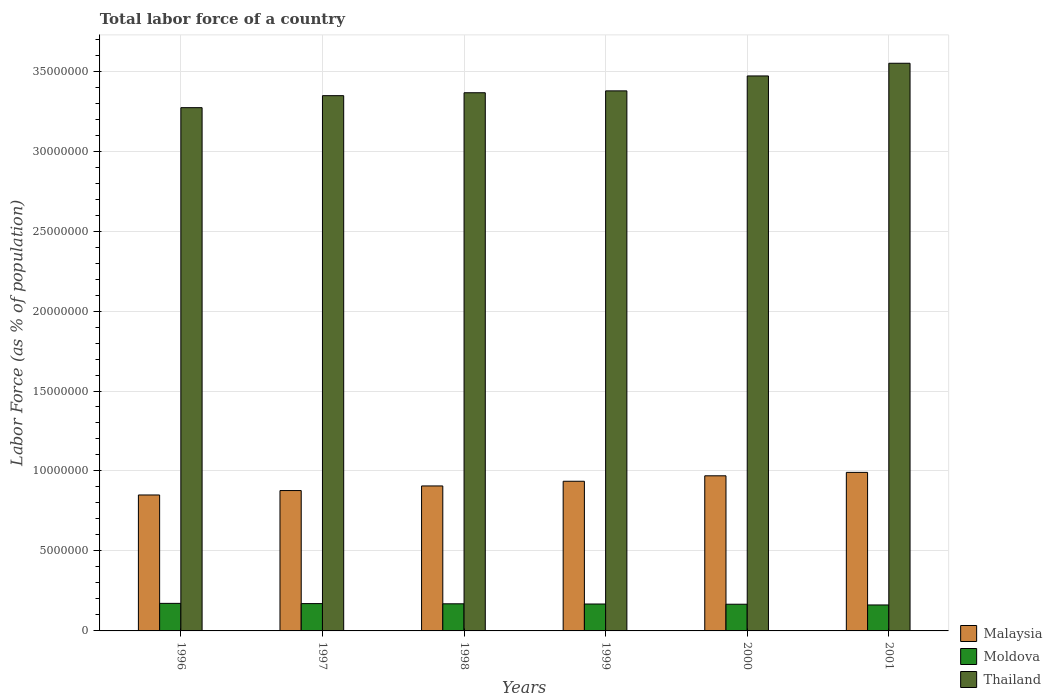How many bars are there on the 4th tick from the right?
Your answer should be very brief. 3. What is the label of the 5th group of bars from the left?
Provide a short and direct response. 2000. What is the percentage of labor force in Moldova in 1997?
Your response must be concise. 1.71e+06. Across all years, what is the maximum percentage of labor force in Moldova?
Your answer should be very brief. 1.72e+06. Across all years, what is the minimum percentage of labor force in Thailand?
Offer a terse response. 3.27e+07. In which year was the percentage of labor force in Thailand minimum?
Your answer should be very brief. 1996. What is the total percentage of labor force in Thailand in the graph?
Your answer should be very brief. 2.04e+08. What is the difference between the percentage of labor force in Moldova in 1997 and that in 1999?
Keep it short and to the point. 2.49e+04. What is the difference between the percentage of labor force in Malaysia in 2000 and the percentage of labor force in Thailand in 2001?
Offer a very short reply. -2.58e+07. What is the average percentage of labor force in Malaysia per year?
Ensure brevity in your answer.  9.22e+06. In the year 1998, what is the difference between the percentage of labor force in Thailand and percentage of labor force in Moldova?
Make the answer very short. 3.20e+07. In how many years, is the percentage of labor force in Thailand greater than 26000000 %?
Your answer should be very brief. 6. What is the ratio of the percentage of labor force in Thailand in 1997 to that in 2000?
Offer a very short reply. 0.96. Is the percentage of labor force in Malaysia in 1996 less than that in 1998?
Your response must be concise. Yes. Is the difference between the percentage of labor force in Thailand in 1996 and 2000 greater than the difference between the percentage of labor force in Moldova in 1996 and 2000?
Your answer should be very brief. No. What is the difference between the highest and the second highest percentage of labor force in Malaysia?
Your answer should be very brief. 2.13e+05. What is the difference between the highest and the lowest percentage of labor force in Thailand?
Your answer should be compact. 2.78e+06. In how many years, is the percentage of labor force in Malaysia greater than the average percentage of labor force in Malaysia taken over all years?
Offer a very short reply. 3. What does the 1st bar from the left in 2000 represents?
Offer a very short reply. Malaysia. What does the 3rd bar from the right in 1999 represents?
Provide a short and direct response. Malaysia. Are all the bars in the graph horizontal?
Offer a very short reply. No. How many years are there in the graph?
Your answer should be very brief. 6. Does the graph contain any zero values?
Your response must be concise. No. Does the graph contain grids?
Offer a terse response. Yes. How many legend labels are there?
Offer a terse response. 3. How are the legend labels stacked?
Provide a succinct answer. Vertical. What is the title of the graph?
Offer a terse response. Total labor force of a country. Does "Kosovo" appear as one of the legend labels in the graph?
Your response must be concise. No. What is the label or title of the Y-axis?
Provide a short and direct response. Labor Force (as % of population). What is the Labor Force (as % of population) in Malaysia in 1996?
Offer a terse response. 8.50e+06. What is the Labor Force (as % of population) in Moldova in 1996?
Give a very brief answer. 1.72e+06. What is the Labor Force (as % of population) of Thailand in 1996?
Keep it short and to the point. 3.27e+07. What is the Labor Force (as % of population) of Malaysia in 1997?
Ensure brevity in your answer.  8.78e+06. What is the Labor Force (as % of population) of Moldova in 1997?
Offer a terse response. 1.71e+06. What is the Labor Force (as % of population) of Thailand in 1997?
Provide a short and direct response. 3.35e+07. What is the Labor Force (as % of population) of Malaysia in 1998?
Your response must be concise. 9.06e+06. What is the Labor Force (as % of population) of Moldova in 1998?
Your answer should be compact. 1.70e+06. What is the Labor Force (as % of population) of Thailand in 1998?
Make the answer very short. 3.36e+07. What is the Labor Force (as % of population) in Malaysia in 1999?
Keep it short and to the point. 9.36e+06. What is the Labor Force (as % of population) in Moldova in 1999?
Your answer should be compact. 1.68e+06. What is the Labor Force (as % of population) of Thailand in 1999?
Your response must be concise. 3.38e+07. What is the Labor Force (as % of population) of Malaysia in 2000?
Keep it short and to the point. 9.70e+06. What is the Labor Force (as % of population) in Moldova in 2000?
Your answer should be very brief. 1.67e+06. What is the Labor Force (as % of population) of Thailand in 2000?
Your answer should be compact. 3.47e+07. What is the Labor Force (as % of population) in Malaysia in 2001?
Your answer should be compact. 9.91e+06. What is the Labor Force (as % of population) of Moldova in 2001?
Your answer should be very brief. 1.62e+06. What is the Labor Force (as % of population) of Thailand in 2001?
Make the answer very short. 3.55e+07. Across all years, what is the maximum Labor Force (as % of population) of Malaysia?
Offer a very short reply. 9.91e+06. Across all years, what is the maximum Labor Force (as % of population) in Moldova?
Offer a terse response. 1.72e+06. Across all years, what is the maximum Labor Force (as % of population) in Thailand?
Your answer should be very brief. 3.55e+07. Across all years, what is the minimum Labor Force (as % of population) in Malaysia?
Your response must be concise. 8.50e+06. Across all years, what is the minimum Labor Force (as % of population) of Moldova?
Offer a very short reply. 1.62e+06. Across all years, what is the minimum Labor Force (as % of population) in Thailand?
Ensure brevity in your answer.  3.27e+07. What is the total Labor Force (as % of population) in Malaysia in the graph?
Ensure brevity in your answer.  5.53e+07. What is the total Labor Force (as % of population) in Moldova in the graph?
Offer a very short reply. 1.01e+07. What is the total Labor Force (as % of population) of Thailand in the graph?
Your answer should be very brief. 2.04e+08. What is the difference between the Labor Force (as % of population) in Malaysia in 1996 and that in 1997?
Your response must be concise. -2.77e+05. What is the difference between the Labor Force (as % of population) of Moldova in 1996 and that in 1997?
Offer a very short reply. 1.54e+04. What is the difference between the Labor Force (as % of population) in Thailand in 1996 and that in 1997?
Offer a very short reply. -7.50e+05. What is the difference between the Labor Force (as % of population) in Malaysia in 1996 and that in 1998?
Your answer should be compact. -5.64e+05. What is the difference between the Labor Force (as % of population) of Moldova in 1996 and that in 1998?
Provide a short and direct response. 2.77e+04. What is the difference between the Labor Force (as % of population) of Thailand in 1996 and that in 1998?
Your response must be concise. -9.32e+05. What is the difference between the Labor Force (as % of population) of Malaysia in 1996 and that in 1999?
Your response must be concise. -8.58e+05. What is the difference between the Labor Force (as % of population) of Moldova in 1996 and that in 1999?
Your response must be concise. 4.03e+04. What is the difference between the Labor Force (as % of population) in Thailand in 1996 and that in 1999?
Provide a succinct answer. -1.05e+06. What is the difference between the Labor Force (as % of population) of Malaysia in 1996 and that in 2000?
Keep it short and to the point. -1.20e+06. What is the difference between the Labor Force (as % of population) in Moldova in 1996 and that in 2000?
Your response must be concise. 5.42e+04. What is the difference between the Labor Force (as % of population) in Thailand in 1996 and that in 2000?
Keep it short and to the point. -1.98e+06. What is the difference between the Labor Force (as % of population) of Malaysia in 1996 and that in 2001?
Your answer should be compact. -1.41e+06. What is the difference between the Labor Force (as % of population) of Moldova in 1996 and that in 2001?
Provide a short and direct response. 9.94e+04. What is the difference between the Labor Force (as % of population) of Thailand in 1996 and that in 2001?
Your answer should be compact. -2.78e+06. What is the difference between the Labor Force (as % of population) in Malaysia in 1997 and that in 1998?
Ensure brevity in your answer.  -2.88e+05. What is the difference between the Labor Force (as % of population) of Moldova in 1997 and that in 1998?
Make the answer very short. 1.23e+04. What is the difference between the Labor Force (as % of population) in Thailand in 1997 and that in 1998?
Provide a succinct answer. -1.82e+05. What is the difference between the Labor Force (as % of population) of Malaysia in 1997 and that in 1999?
Provide a short and direct response. -5.81e+05. What is the difference between the Labor Force (as % of population) in Moldova in 1997 and that in 1999?
Provide a short and direct response. 2.49e+04. What is the difference between the Labor Force (as % of population) of Thailand in 1997 and that in 1999?
Offer a very short reply. -2.99e+05. What is the difference between the Labor Force (as % of population) in Malaysia in 1997 and that in 2000?
Your answer should be compact. -9.22e+05. What is the difference between the Labor Force (as % of population) of Moldova in 1997 and that in 2000?
Offer a very short reply. 3.88e+04. What is the difference between the Labor Force (as % of population) in Thailand in 1997 and that in 2000?
Make the answer very short. -1.23e+06. What is the difference between the Labor Force (as % of population) in Malaysia in 1997 and that in 2001?
Provide a succinct answer. -1.14e+06. What is the difference between the Labor Force (as % of population) in Moldova in 1997 and that in 2001?
Your response must be concise. 8.40e+04. What is the difference between the Labor Force (as % of population) of Thailand in 1997 and that in 2001?
Your response must be concise. -2.03e+06. What is the difference between the Labor Force (as % of population) of Malaysia in 1998 and that in 1999?
Keep it short and to the point. -2.93e+05. What is the difference between the Labor Force (as % of population) of Moldova in 1998 and that in 1999?
Make the answer very short. 1.26e+04. What is the difference between the Labor Force (as % of population) of Thailand in 1998 and that in 1999?
Ensure brevity in your answer.  -1.17e+05. What is the difference between the Labor Force (as % of population) of Malaysia in 1998 and that in 2000?
Your answer should be compact. -6.34e+05. What is the difference between the Labor Force (as % of population) of Moldova in 1998 and that in 2000?
Provide a succinct answer. 2.65e+04. What is the difference between the Labor Force (as % of population) in Thailand in 1998 and that in 2000?
Offer a terse response. -1.05e+06. What is the difference between the Labor Force (as % of population) in Malaysia in 1998 and that in 2001?
Your answer should be compact. -8.48e+05. What is the difference between the Labor Force (as % of population) of Moldova in 1998 and that in 2001?
Keep it short and to the point. 7.17e+04. What is the difference between the Labor Force (as % of population) of Thailand in 1998 and that in 2001?
Make the answer very short. -1.84e+06. What is the difference between the Labor Force (as % of population) in Malaysia in 1999 and that in 2000?
Your answer should be compact. -3.41e+05. What is the difference between the Labor Force (as % of population) of Moldova in 1999 and that in 2000?
Your response must be concise. 1.39e+04. What is the difference between the Labor Force (as % of population) in Thailand in 1999 and that in 2000?
Give a very brief answer. -9.33e+05. What is the difference between the Labor Force (as % of population) of Malaysia in 1999 and that in 2001?
Make the answer very short. -5.55e+05. What is the difference between the Labor Force (as % of population) in Moldova in 1999 and that in 2001?
Your answer should be very brief. 5.91e+04. What is the difference between the Labor Force (as % of population) in Thailand in 1999 and that in 2001?
Ensure brevity in your answer.  -1.73e+06. What is the difference between the Labor Force (as % of population) of Malaysia in 2000 and that in 2001?
Provide a succinct answer. -2.13e+05. What is the difference between the Labor Force (as % of population) of Moldova in 2000 and that in 2001?
Offer a very short reply. 4.52e+04. What is the difference between the Labor Force (as % of population) of Thailand in 2000 and that in 2001?
Offer a very short reply. -7.93e+05. What is the difference between the Labor Force (as % of population) of Malaysia in 1996 and the Labor Force (as % of population) of Moldova in 1997?
Ensure brevity in your answer.  6.79e+06. What is the difference between the Labor Force (as % of population) in Malaysia in 1996 and the Labor Force (as % of population) in Thailand in 1997?
Your response must be concise. -2.50e+07. What is the difference between the Labor Force (as % of population) of Moldova in 1996 and the Labor Force (as % of population) of Thailand in 1997?
Make the answer very short. -3.17e+07. What is the difference between the Labor Force (as % of population) in Malaysia in 1996 and the Labor Force (as % of population) in Moldova in 1998?
Keep it short and to the point. 6.80e+06. What is the difference between the Labor Force (as % of population) of Malaysia in 1996 and the Labor Force (as % of population) of Thailand in 1998?
Offer a terse response. -2.51e+07. What is the difference between the Labor Force (as % of population) of Moldova in 1996 and the Labor Force (as % of population) of Thailand in 1998?
Ensure brevity in your answer.  -3.19e+07. What is the difference between the Labor Force (as % of population) in Malaysia in 1996 and the Labor Force (as % of population) in Moldova in 1999?
Offer a very short reply. 6.82e+06. What is the difference between the Labor Force (as % of population) of Malaysia in 1996 and the Labor Force (as % of population) of Thailand in 1999?
Your answer should be very brief. -2.53e+07. What is the difference between the Labor Force (as % of population) in Moldova in 1996 and the Labor Force (as % of population) in Thailand in 1999?
Your answer should be very brief. -3.20e+07. What is the difference between the Labor Force (as % of population) in Malaysia in 1996 and the Labor Force (as % of population) in Moldova in 2000?
Keep it short and to the point. 6.83e+06. What is the difference between the Labor Force (as % of population) in Malaysia in 1996 and the Labor Force (as % of population) in Thailand in 2000?
Your answer should be compact. -2.62e+07. What is the difference between the Labor Force (as % of population) of Moldova in 1996 and the Labor Force (as % of population) of Thailand in 2000?
Ensure brevity in your answer.  -3.30e+07. What is the difference between the Labor Force (as % of population) in Malaysia in 1996 and the Labor Force (as % of population) in Moldova in 2001?
Offer a terse response. 6.88e+06. What is the difference between the Labor Force (as % of population) in Malaysia in 1996 and the Labor Force (as % of population) in Thailand in 2001?
Offer a terse response. -2.70e+07. What is the difference between the Labor Force (as % of population) in Moldova in 1996 and the Labor Force (as % of population) in Thailand in 2001?
Ensure brevity in your answer.  -3.38e+07. What is the difference between the Labor Force (as % of population) of Malaysia in 1997 and the Labor Force (as % of population) of Moldova in 1998?
Offer a terse response. 7.08e+06. What is the difference between the Labor Force (as % of population) in Malaysia in 1997 and the Labor Force (as % of population) in Thailand in 1998?
Provide a short and direct response. -2.49e+07. What is the difference between the Labor Force (as % of population) of Moldova in 1997 and the Labor Force (as % of population) of Thailand in 1998?
Offer a very short reply. -3.19e+07. What is the difference between the Labor Force (as % of population) of Malaysia in 1997 and the Labor Force (as % of population) of Moldova in 1999?
Keep it short and to the point. 7.09e+06. What is the difference between the Labor Force (as % of population) of Malaysia in 1997 and the Labor Force (as % of population) of Thailand in 1999?
Keep it short and to the point. -2.50e+07. What is the difference between the Labor Force (as % of population) of Moldova in 1997 and the Labor Force (as % of population) of Thailand in 1999?
Make the answer very short. -3.21e+07. What is the difference between the Labor Force (as % of population) in Malaysia in 1997 and the Labor Force (as % of population) in Moldova in 2000?
Provide a succinct answer. 7.11e+06. What is the difference between the Labor Force (as % of population) of Malaysia in 1997 and the Labor Force (as % of population) of Thailand in 2000?
Make the answer very short. -2.59e+07. What is the difference between the Labor Force (as % of population) in Moldova in 1997 and the Labor Force (as % of population) in Thailand in 2000?
Provide a succinct answer. -3.30e+07. What is the difference between the Labor Force (as % of population) in Malaysia in 1997 and the Labor Force (as % of population) in Moldova in 2001?
Provide a short and direct response. 7.15e+06. What is the difference between the Labor Force (as % of population) of Malaysia in 1997 and the Labor Force (as % of population) of Thailand in 2001?
Offer a terse response. -2.67e+07. What is the difference between the Labor Force (as % of population) in Moldova in 1997 and the Labor Force (as % of population) in Thailand in 2001?
Offer a very short reply. -3.38e+07. What is the difference between the Labor Force (as % of population) of Malaysia in 1998 and the Labor Force (as % of population) of Moldova in 1999?
Keep it short and to the point. 7.38e+06. What is the difference between the Labor Force (as % of population) of Malaysia in 1998 and the Labor Force (as % of population) of Thailand in 1999?
Your answer should be compact. -2.47e+07. What is the difference between the Labor Force (as % of population) in Moldova in 1998 and the Labor Force (as % of population) in Thailand in 1999?
Provide a succinct answer. -3.21e+07. What is the difference between the Labor Force (as % of population) in Malaysia in 1998 and the Labor Force (as % of population) in Moldova in 2000?
Your answer should be compact. 7.40e+06. What is the difference between the Labor Force (as % of population) of Malaysia in 1998 and the Labor Force (as % of population) of Thailand in 2000?
Give a very brief answer. -2.56e+07. What is the difference between the Labor Force (as % of population) in Moldova in 1998 and the Labor Force (as % of population) in Thailand in 2000?
Keep it short and to the point. -3.30e+07. What is the difference between the Labor Force (as % of population) of Malaysia in 1998 and the Labor Force (as % of population) of Moldova in 2001?
Your answer should be compact. 7.44e+06. What is the difference between the Labor Force (as % of population) of Malaysia in 1998 and the Labor Force (as % of population) of Thailand in 2001?
Provide a succinct answer. -2.64e+07. What is the difference between the Labor Force (as % of population) in Moldova in 1998 and the Labor Force (as % of population) in Thailand in 2001?
Keep it short and to the point. -3.38e+07. What is the difference between the Labor Force (as % of population) in Malaysia in 1999 and the Labor Force (as % of population) in Moldova in 2000?
Offer a very short reply. 7.69e+06. What is the difference between the Labor Force (as % of population) of Malaysia in 1999 and the Labor Force (as % of population) of Thailand in 2000?
Give a very brief answer. -2.53e+07. What is the difference between the Labor Force (as % of population) in Moldova in 1999 and the Labor Force (as % of population) in Thailand in 2000?
Your answer should be compact. -3.30e+07. What is the difference between the Labor Force (as % of population) in Malaysia in 1999 and the Labor Force (as % of population) in Moldova in 2001?
Your response must be concise. 7.73e+06. What is the difference between the Labor Force (as % of population) of Malaysia in 1999 and the Labor Force (as % of population) of Thailand in 2001?
Offer a very short reply. -2.61e+07. What is the difference between the Labor Force (as % of population) in Moldova in 1999 and the Labor Force (as % of population) in Thailand in 2001?
Provide a short and direct response. -3.38e+07. What is the difference between the Labor Force (as % of population) of Malaysia in 2000 and the Labor Force (as % of population) of Moldova in 2001?
Give a very brief answer. 8.07e+06. What is the difference between the Labor Force (as % of population) of Malaysia in 2000 and the Labor Force (as % of population) of Thailand in 2001?
Provide a short and direct response. -2.58e+07. What is the difference between the Labor Force (as % of population) in Moldova in 2000 and the Labor Force (as % of population) in Thailand in 2001?
Your answer should be very brief. -3.38e+07. What is the average Labor Force (as % of population) of Malaysia per year?
Make the answer very short. 9.22e+06. What is the average Labor Force (as % of population) of Moldova per year?
Give a very brief answer. 1.68e+06. What is the average Labor Force (as % of population) in Thailand per year?
Keep it short and to the point. 3.40e+07. In the year 1996, what is the difference between the Labor Force (as % of population) of Malaysia and Labor Force (as % of population) of Moldova?
Provide a short and direct response. 6.78e+06. In the year 1996, what is the difference between the Labor Force (as % of population) in Malaysia and Labor Force (as % of population) in Thailand?
Provide a succinct answer. -2.42e+07. In the year 1996, what is the difference between the Labor Force (as % of population) in Moldova and Labor Force (as % of population) in Thailand?
Your response must be concise. -3.10e+07. In the year 1997, what is the difference between the Labor Force (as % of population) in Malaysia and Labor Force (as % of population) in Moldova?
Give a very brief answer. 7.07e+06. In the year 1997, what is the difference between the Labor Force (as % of population) of Malaysia and Labor Force (as % of population) of Thailand?
Your response must be concise. -2.47e+07. In the year 1997, what is the difference between the Labor Force (as % of population) of Moldova and Labor Force (as % of population) of Thailand?
Your response must be concise. -3.18e+07. In the year 1998, what is the difference between the Labor Force (as % of population) in Malaysia and Labor Force (as % of population) in Moldova?
Ensure brevity in your answer.  7.37e+06. In the year 1998, what is the difference between the Labor Force (as % of population) of Malaysia and Labor Force (as % of population) of Thailand?
Your answer should be compact. -2.46e+07. In the year 1998, what is the difference between the Labor Force (as % of population) in Moldova and Labor Force (as % of population) in Thailand?
Make the answer very short. -3.20e+07. In the year 1999, what is the difference between the Labor Force (as % of population) of Malaysia and Labor Force (as % of population) of Moldova?
Offer a terse response. 7.67e+06. In the year 1999, what is the difference between the Labor Force (as % of population) in Malaysia and Labor Force (as % of population) in Thailand?
Offer a terse response. -2.44e+07. In the year 1999, what is the difference between the Labor Force (as % of population) of Moldova and Labor Force (as % of population) of Thailand?
Provide a succinct answer. -3.21e+07. In the year 2000, what is the difference between the Labor Force (as % of population) of Malaysia and Labor Force (as % of population) of Moldova?
Your answer should be very brief. 8.03e+06. In the year 2000, what is the difference between the Labor Force (as % of population) in Malaysia and Labor Force (as % of population) in Thailand?
Offer a very short reply. -2.50e+07. In the year 2000, what is the difference between the Labor Force (as % of population) in Moldova and Labor Force (as % of population) in Thailand?
Keep it short and to the point. -3.30e+07. In the year 2001, what is the difference between the Labor Force (as % of population) of Malaysia and Labor Force (as % of population) of Moldova?
Offer a terse response. 8.29e+06. In the year 2001, what is the difference between the Labor Force (as % of population) of Malaysia and Labor Force (as % of population) of Thailand?
Provide a succinct answer. -2.56e+07. In the year 2001, what is the difference between the Labor Force (as % of population) in Moldova and Labor Force (as % of population) in Thailand?
Your answer should be compact. -3.39e+07. What is the ratio of the Labor Force (as % of population) of Malaysia in 1996 to that in 1997?
Your answer should be compact. 0.97. What is the ratio of the Labor Force (as % of population) in Moldova in 1996 to that in 1997?
Make the answer very short. 1.01. What is the ratio of the Labor Force (as % of population) of Thailand in 1996 to that in 1997?
Offer a terse response. 0.98. What is the ratio of the Labor Force (as % of population) of Malaysia in 1996 to that in 1998?
Provide a succinct answer. 0.94. What is the ratio of the Labor Force (as % of population) in Moldova in 1996 to that in 1998?
Ensure brevity in your answer.  1.02. What is the ratio of the Labor Force (as % of population) in Thailand in 1996 to that in 1998?
Provide a short and direct response. 0.97. What is the ratio of the Labor Force (as % of population) in Malaysia in 1996 to that in 1999?
Your answer should be compact. 0.91. What is the ratio of the Labor Force (as % of population) in Moldova in 1996 to that in 1999?
Your answer should be compact. 1.02. What is the ratio of the Labor Force (as % of population) of Thailand in 1996 to that in 1999?
Your answer should be compact. 0.97. What is the ratio of the Labor Force (as % of population) of Malaysia in 1996 to that in 2000?
Provide a short and direct response. 0.88. What is the ratio of the Labor Force (as % of population) of Moldova in 1996 to that in 2000?
Provide a short and direct response. 1.03. What is the ratio of the Labor Force (as % of population) in Thailand in 1996 to that in 2000?
Give a very brief answer. 0.94. What is the ratio of the Labor Force (as % of population) in Malaysia in 1996 to that in 2001?
Give a very brief answer. 0.86. What is the ratio of the Labor Force (as % of population) in Moldova in 1996 to that in 2001?
Your answer should be compact. 1.06. What is the ratio of the Labor Force (as % of population) in Thailand in 1996 to that in 2001?
Provide a short and direct response. 0.92. What is the ratio of the Labor Force (as % of population) in Malaysia in 1997 to that in 1998?
Provide a short and direct response. 0.97. What is the ratio of the Labor Force (as % of population) in Moldova in 1997 to that in 1998?
Provide a short and direct response. 1.01. What is the ratio of the Labor Force (as % of population) of Thailand in 1997 to that in 1998?
Ensure brevity in your answer.  0.99. What is the ratio of the Labor Force (as % of population) of Malaysia in 1997 to that in 1999?
Your response must be concise. 0.94. What is the ratio of the Labor Force (as % of population) in Moldova in 1997 to that in 1999?
Your answer should be very brief. 1.01. What is the ratio of the Labor Force (as % of population) of Thailand in 1997 to that in 1999?
Give a very brief answer. 0.99. What is the ratio of the Labor Force (as % of population) of Malaysia in 1997 to that in 2000?
Ensure brevity in your answer.  0.9. What is the ratio of the Labor Force (as % of population) in Moldova in 1997 to that in 2000?
Keep it short and to the point. 1.02. What is the ratio of the Labor Force (as % of population) in Thailand in 1997 to that in 2000?
Your answer should be compact. 0.96. What is the ratio of the Labor Force (as % of population) of Malaysia in 1997 to that in 2001?
Offer a very short reply. 0.89. What is the ratio of the Labor Force (as % of population) of Moldova in 1997 to that in 2001?
Give a very brief answer. 1.05. What is the ratio of the Labor Force (as % of population) of Thailand in 1997 to that in 2001?
Your answer should be very brief. 0.94. What is the ratio of the Labor Force (as % of population) of Malaysia in 1998 to that in 1999?
Offer a terse response. 0.97. What is the ratio of the Labor Force (as % of population) in Moldova in 1998 to that in 1999?
Make the answer very short. 1.01. What is the ratio of the Labor Force (as % of population) in Malaysia in 1998 to that in 2000?
Offer a terse response. 0.93. What is the ratio of the Labor Force (as % of population) in Moldova in 1998 to that in 2000?
Provide a short and direct response. 1.02. What is the ratio of the Labor Force (as % of population) in Thailand in 1998 to that in 2000?
Make the answer very short. 0.97. What is the ratio of the Labor Force (as % of population) of Malaysia in 1998 to that in 2001?
Your answer should be very brief. 0.91. What is the ratio of the Labor Force (as % of population) of Moldova in 1998 to that in 2001?
Give a very brief answer. 1.04. What is the ratio of the Labor Force (as % of population) of Thailand in 1998 to that in 2001?
Your response must be concise. 0.95. What is the ratio of the Labor Force (as % of population) in Malaysia in 1999 to that in 2000?
Ensure brevity in your answer.  0.96. What is the ratio of the Labor Force (as % of population) in Moldova in 1999 to that in 2000?
Ensure brevity in your answer.  1.01. What is the ratio of the Labor Force (as % of population) in Thailand in 1999 to that in 2000?
Offer a terse response. 0.97. What is the ratio of the Labor Force (as % of population) in Malaysia in 1999 to that in 2001?
Make the answer very short. 0.94. What is the ratio of the Labor Force (as % of population) of Moldova in 1999 to that in 2001?
Make the answer very short. 1.04. What is the ratio of the Labor Force (as % of population) of Thailand in 1999 to that in 2001?
Your response must be concise. 0.95. What is the ratio of the Labor Force (as % of population) of Malaysia in 2000 to that in 2001?
Offer a very short reply. 0.98. What is the ratio of the Labor Force (as % of population) in Moldova in 2000 to that in 2001?
Your answer should be compact. 1.03. What is the ratio of the Labor Force (as % of population) in Thailand in 2000 to that in 2001?
Provide a succinct answer. 0.98. What is the difference between the highest and the second highest Labor Force (as % of population) of Malaysia?
Keep it short and to the point. 2.13e+05. What is the difference between the highest and the second highest Labor Force (as % of population) in Moldova?
Provide a short and direct response. 1.54e+04. What is the difference between the highest and the second highest Labor Force (as % of population) of Thailand?
Your answer should be compact. 7.93e+05. What is the difference between the highest and the lowest Labor Force (as % of population) of Malaysia?
Provide a short and direct response. 1.41e+06. What is the difference between the highest and the lowest Labor Force (as % of population) of Moldova?
Make the answer very short. 9.94e+04. What is the difference between the highest and the lowest Labor Force (as % of population) of Thailand?
Make the answer very short. 2.78e+06. 